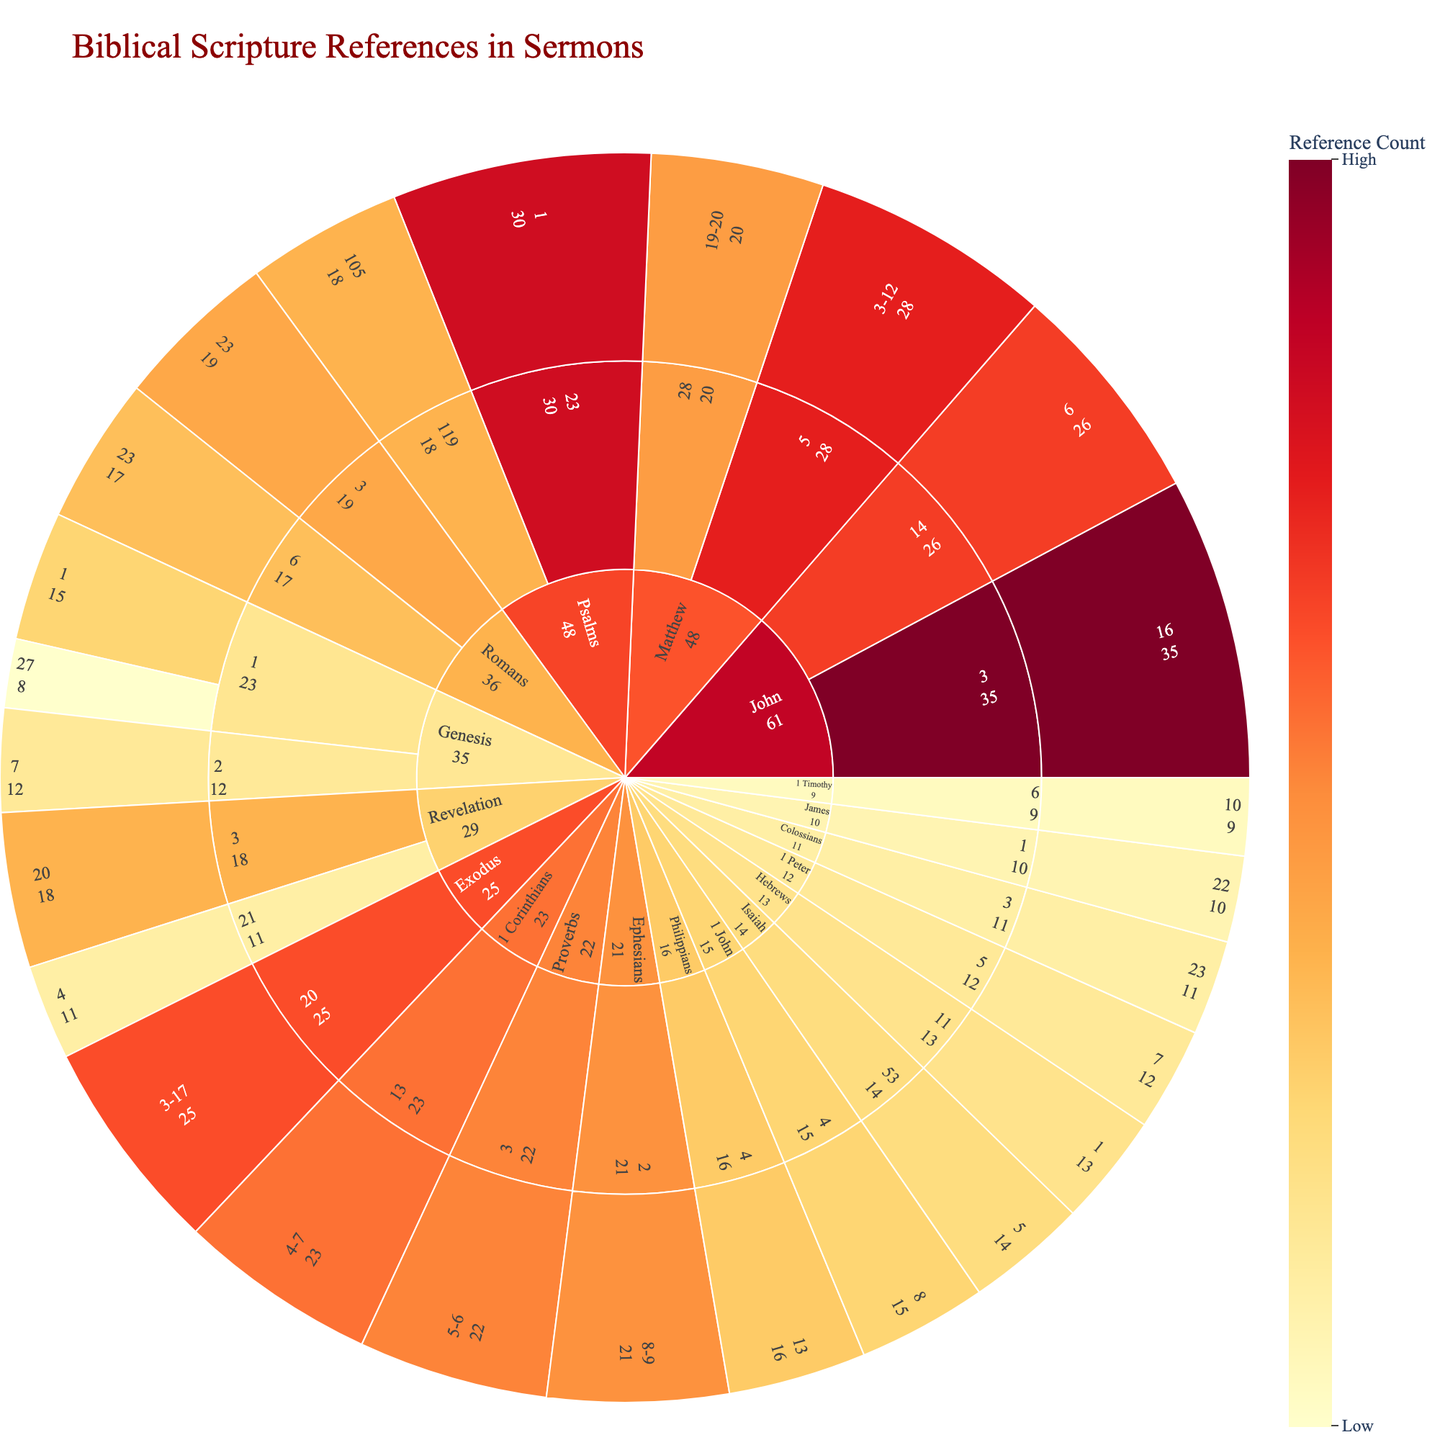Which book has the highest number of scripture references? By looking at the center node in the sunburst plot, we can see which book has the largest portion. 'John' has the largest segment.
Answer: John What is the total reference count of the Book of Matthew? The total reference count is the sum of all verses within the Book of Matthew: 28 for Matthew 5:3-12 and 20 for Matthew 28:19-20. Thus, 28 + 20 = 48.
Answer: 48 Which chapter in Psalms has more references, chapter 23 or chapter 119? We compare the segment sizes or values for Psalms 23:1 (30) and Psalms 119:105 (18). Psalms 23 has more references.
Answer: Psalms 23 How many books have verses with reference counts greater than 20? By inspecting the plot, we identify which books have verses with counts exceeding 20: Psalms, Matthew, John, Proverbs, Romans, and 1 Corinthians. This counts to 6 books.
Answer: 6 What's the reference count difference between verses John 3:16 and John 14:6? The reference count for John 3:16 is 35 and for John 14:6 is 26. The difference is 35 - 26 = 9.
Answer: 9 Which verse has the highest reference count? By finding the largest segment in the sunburst plot, we see John 3:16 has the highest count, which is 35.
Answer: John 3:16 Which has more references: Isaiah 53:5 or Proverbs 3:5-6? By comparing their values, Isaiah 53:5 has 14 references while Proverbs 3:5-6 has 22. Thus, Proverbs 3:5-6 has more references.
Answer: Proverbs 3:5-6 What is the sum of references for Genesis 1:1 and Genesis 2:7? The reference counts are 15 and 12 respectively. The sum is 15 + 12 = 27.
Answer: 27 Are there any books where the reference count is consistent across all chapters? By observing the plot, we see that most books have varying counts across chapters. Therefore, there are no books with consistent reference counts.
Answer: No 